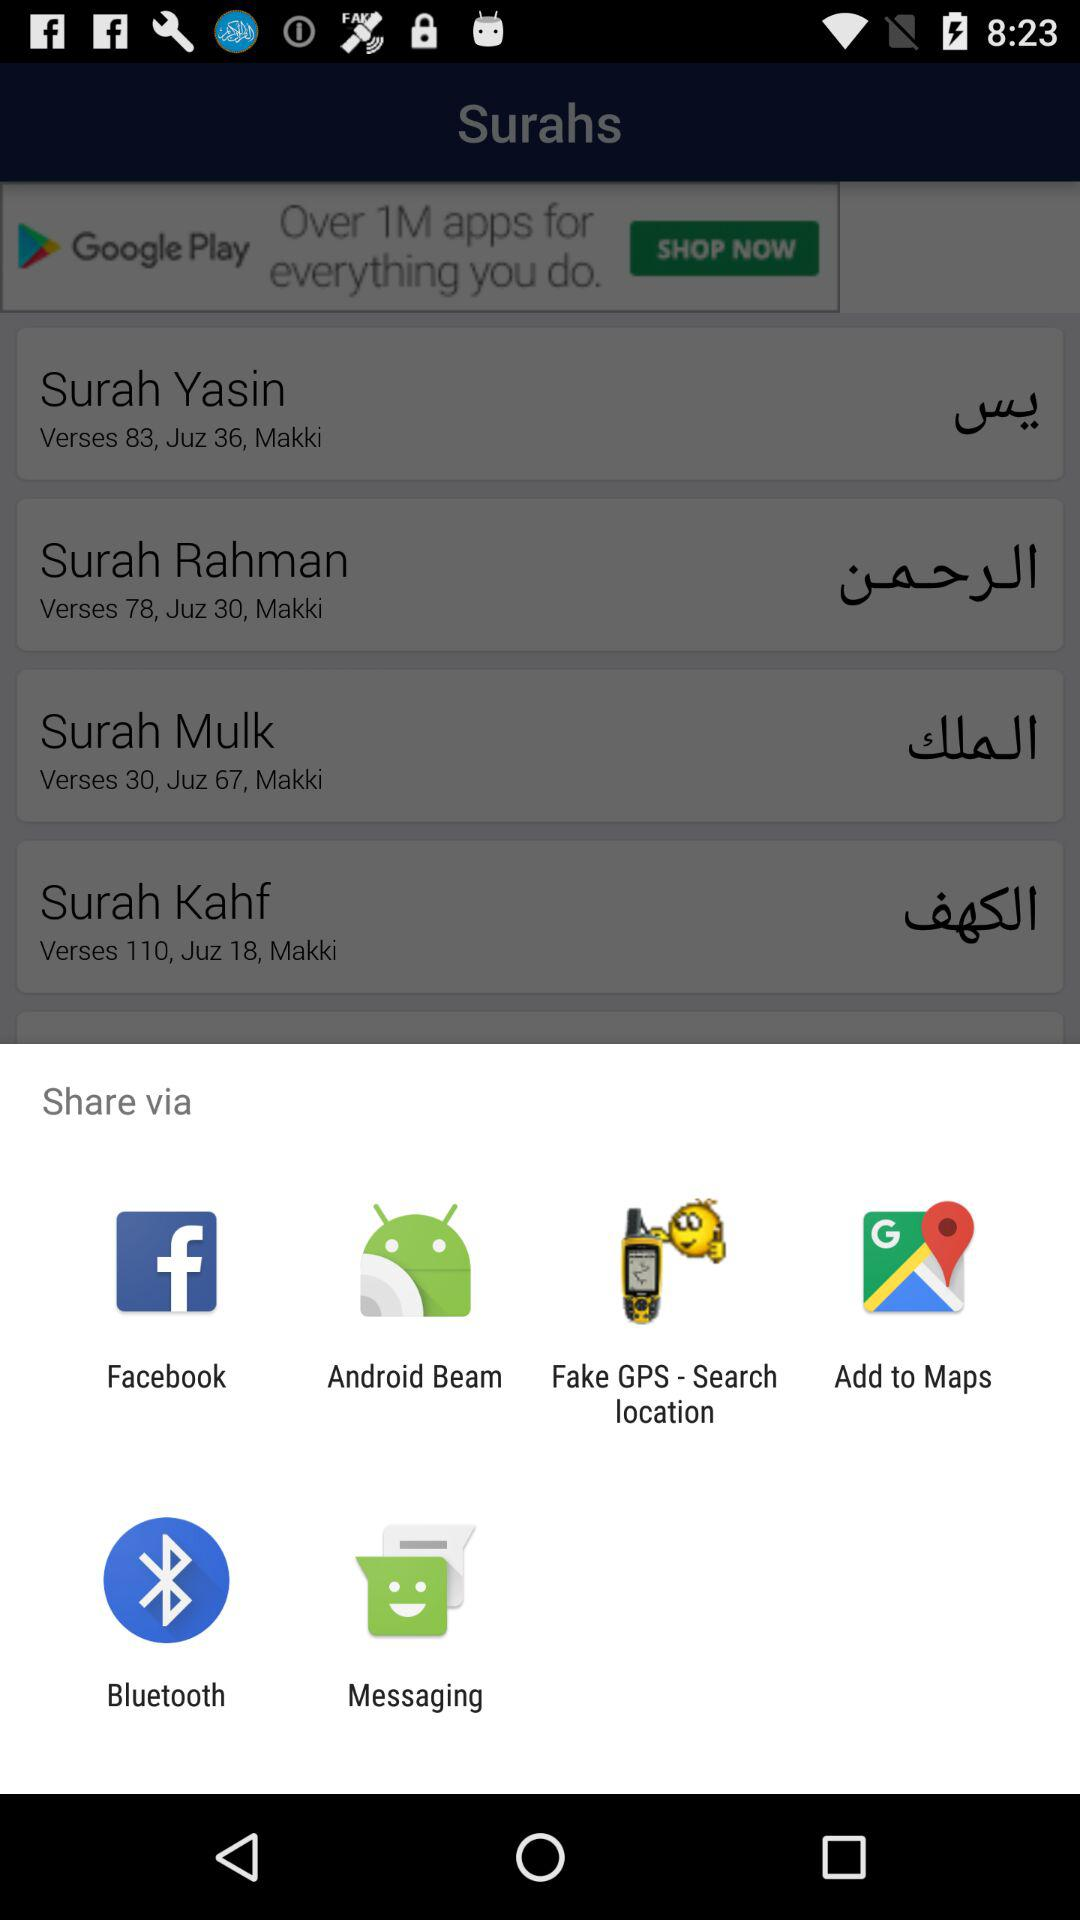Through which applications or mediums can the content be shared? The content can be shared through "Facebook", "Android Beam", "Fake GPS - Search location", "Add to Maps", "Bluetooth" and "Messaging". 